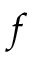Convert formula to latex. <formula><loc_0><loc_0><loc_500><loc_500>f</formula> 